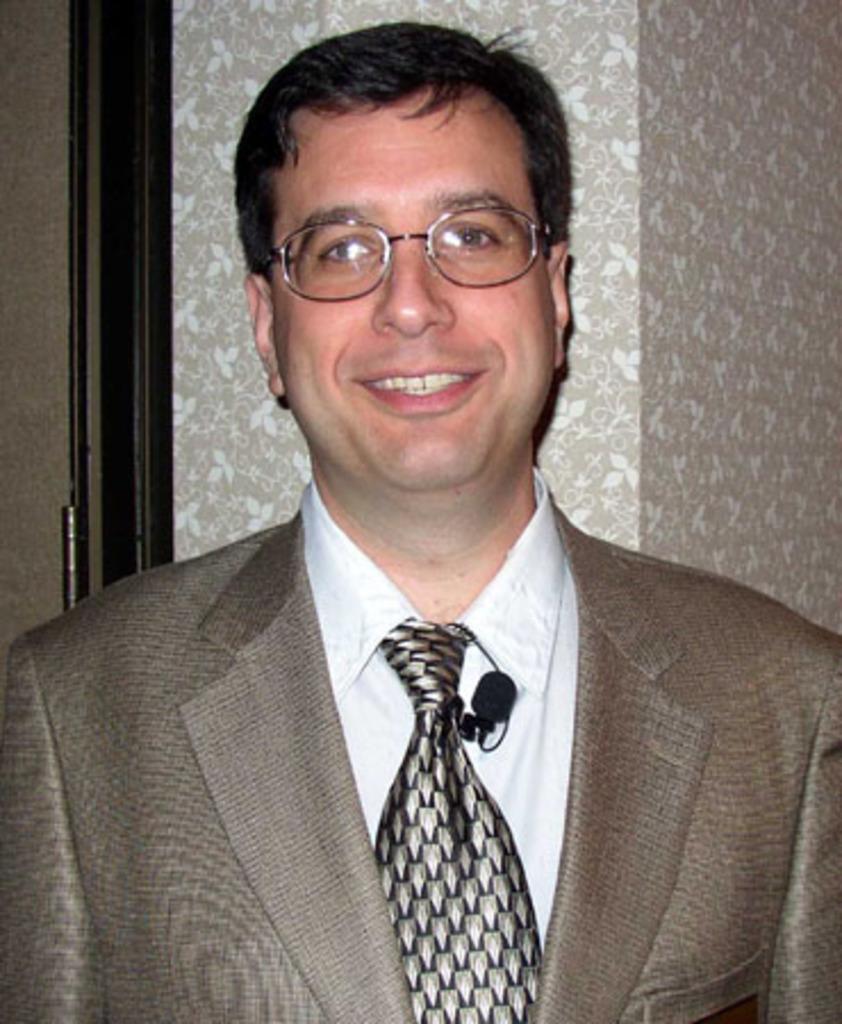Could you give a brief overview of what you see in this image? In this picture we can see a man wearing a brown color suit and standing in the front, smiling and giving a pose into the camera. Behind there is a wallpaper on the wall and door. 